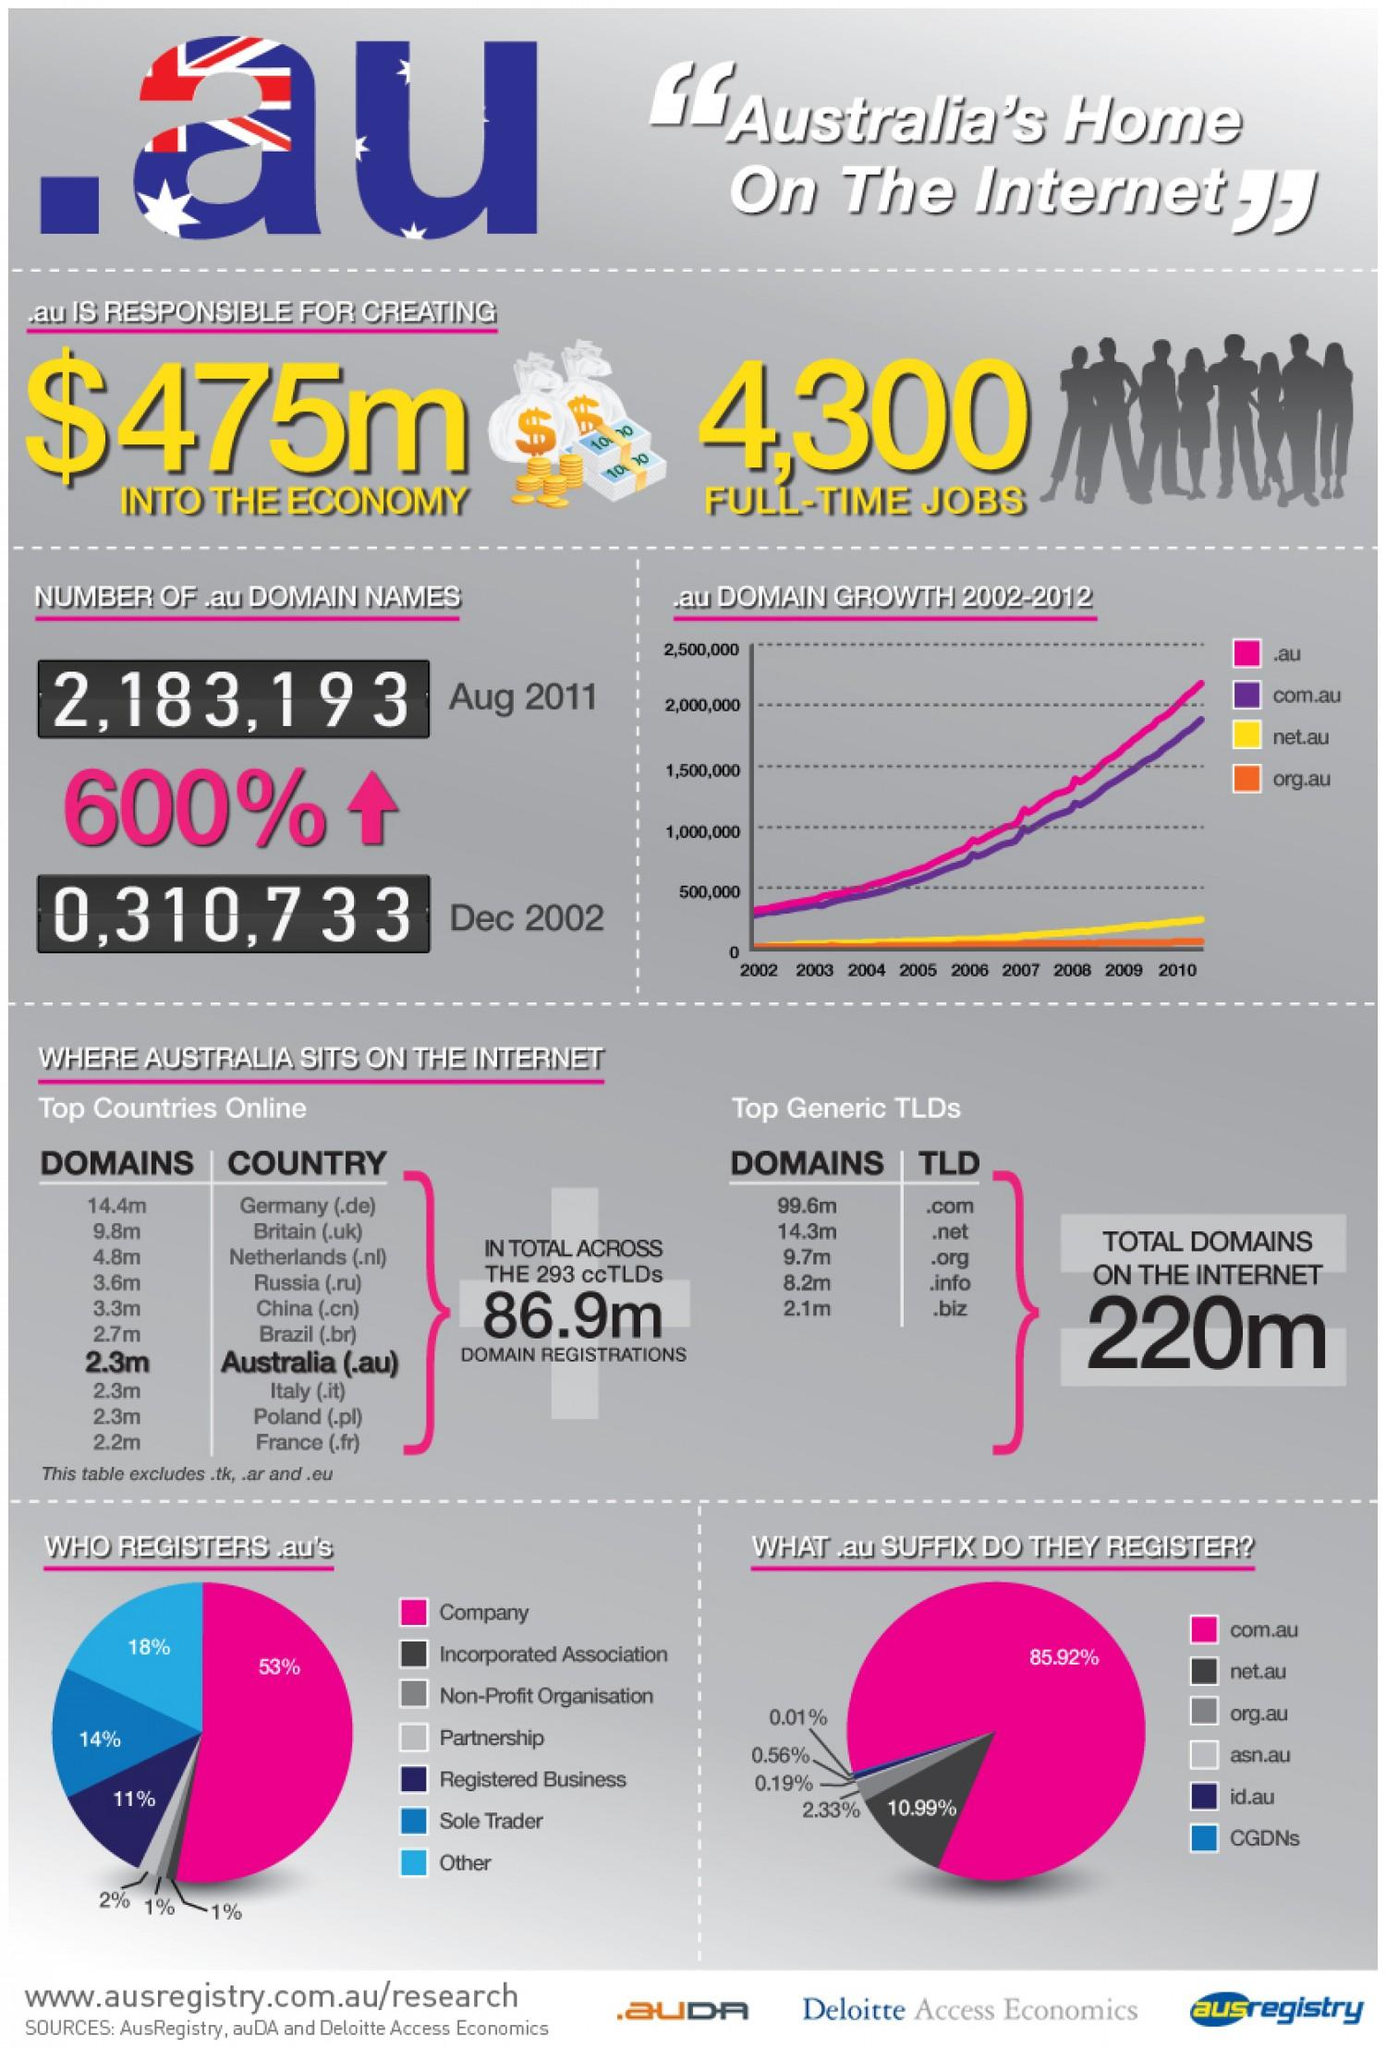Draw attention to some important aspects in this diagram. According to the latest statistics, 55% of companies and partnerships have registered for domain names ending in .au. The domain growth of com.au has been the second highest. The increase in .au domain names from 2002 to 2011 was approximately 600%. Australian domains are higher than those of France. The domain name "net.au" is used by 10.99% of registrants. 